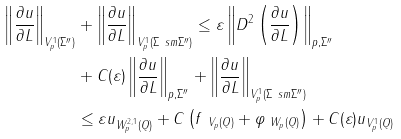<formula> <loc_0><loc_0><loc_500><loc_500>\left \| \frac { \partial u } { \partial L } \right \| _ { V ^ { 1 } _ { p } ( \Sigma ^ { \prime \prime } ) } & + \left \| \frac { \partial u } { \partial L } \right \| _ { V ^ { 1 } _ { p } ( \Sigma \ s m \Sigma ^ { \prime \prime } ) } \leq \varepsilon \left \| D ^ { 2 } \left ( \frac { \partial u } { \partial L } \right ) \right \| _ { p , \Sigma ^ { \prime \prime } } \\ & + C ( \varepsilon ) \left \| \frac { \partial u } { \partial L } \right \| _ { p , \Sigma ^ { \prime \prime } } + \left \| \frac { \partial u } { \partial L } \right \| _ { V ^ { 1 } _ { p } ( \Sigma \ s m \Sigma ^ { \prime \prime } ) } \\ & \leq \varepsilon \| u \| _ { W ^ { 2 , 1 } _ { p } ( Q ) } + C \left ( \| f \| _ { \ V _ { p } ( Q ) } + \| \varphi \| _ { \ W _ { p } ( Q ) } \right ) + C ( \varepsilon ) \| u \| _ { V ^ { 1 } _ { p } ( Q ) }</formula> 